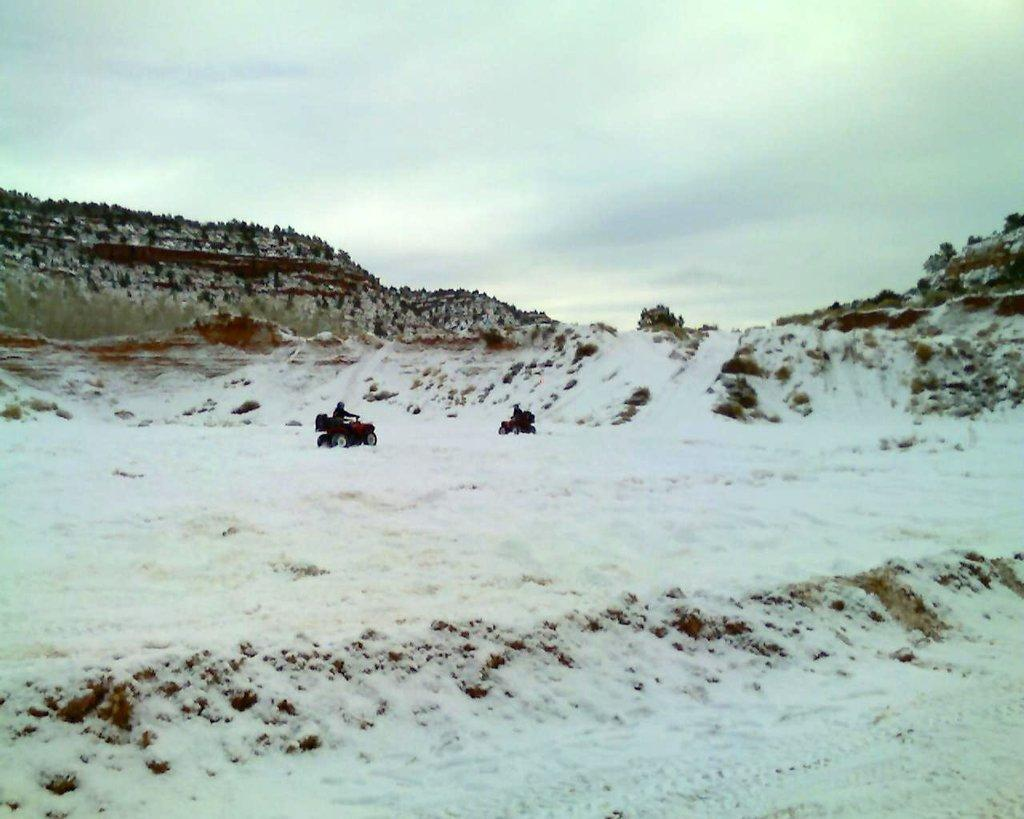Who or what is present in the image? There is a person in the image. What else can be seen in the image besides the person? There are vehicles, snow, mountains, grass, and the sky visible in the image. Can you describe the environment in the image? The image features a snowy landscape with mountains and grass, and the sky is visible. How many women are present in the image? There is no mention of women in the image; only a person is mentioned. What type of knot can be seen in the image? There is no knot present in the image. 